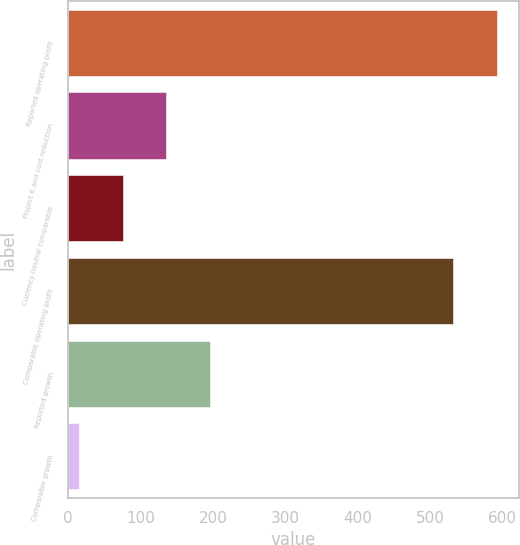Convert chart to OTSL. <chart><loc_0><loc_0><loc_500><loc_500><bar_chart><fcel>Reported operating profit<fcel>Project K and cost reduction<fcel>Currency-neutral comparable<fcel>Comparable operating profit<fcel>Reported growth<fcel>Comparable growth<nl><fcel>593<fcel>135.76<fcel>75.73<fcel>532<fcel>195.79<fcel>15.7<nl></chart> 